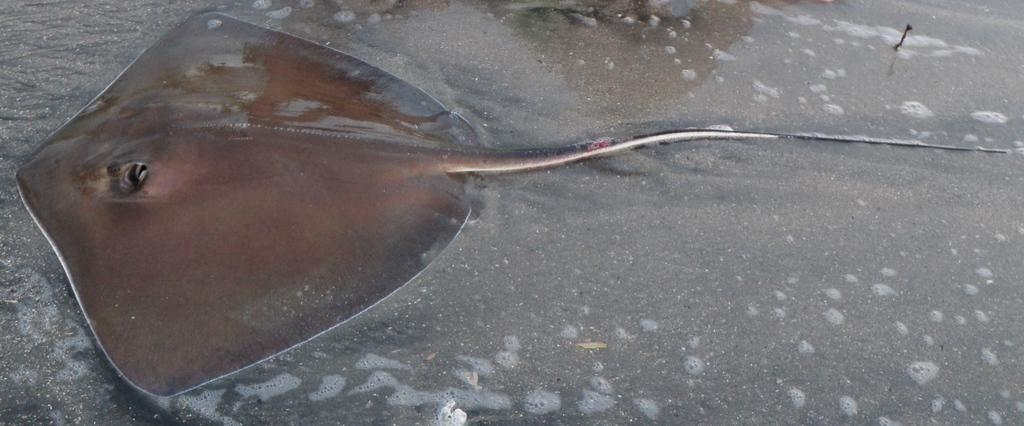What type of fish is in the picture? There is a skate fish in the picture. What color is the skate fish? The skate fish is brown in color. What can be seen in the background of the picture? There is water and sand visible in the background of the picture. What type of ring can be seen on the skate fish's fin in the image? There is no ring present on the skate fish's fin in the image. What type of industry is depicted in the background of the image? There is no industry present in the image; it features a skate fish in water and sand. 